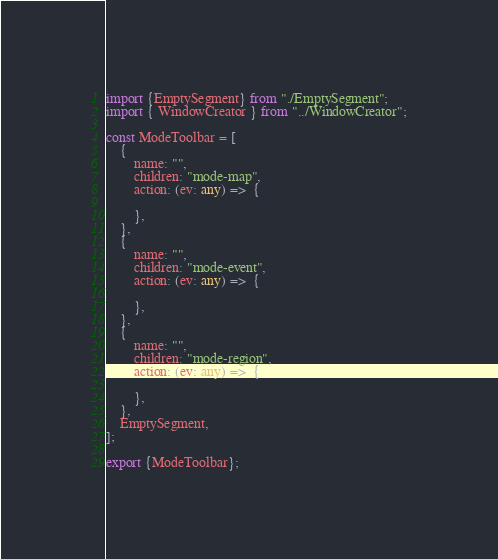<code> <loc_0><loc_0><loc_500><loc_500><_TypeScript_>import {EmptySegment} from "./EmptySegment";
import { WindowCreator } from "../WindowCreator";

const ModeToolbar = [
    {
        name: "",
        children: "mode-map",
        action: (ev: any) =>  {
            
        },           
    },
    {
        name: "",
        children: "mode-event",
        action: (ev: any) =>  {
            
        },           
    },
    {
        name: "",
        children: "mode-region",
        action: (ev: any) =>  {
            
        },           
    },
    EmptySegment,
];

export {ModeToolbar};</code> 